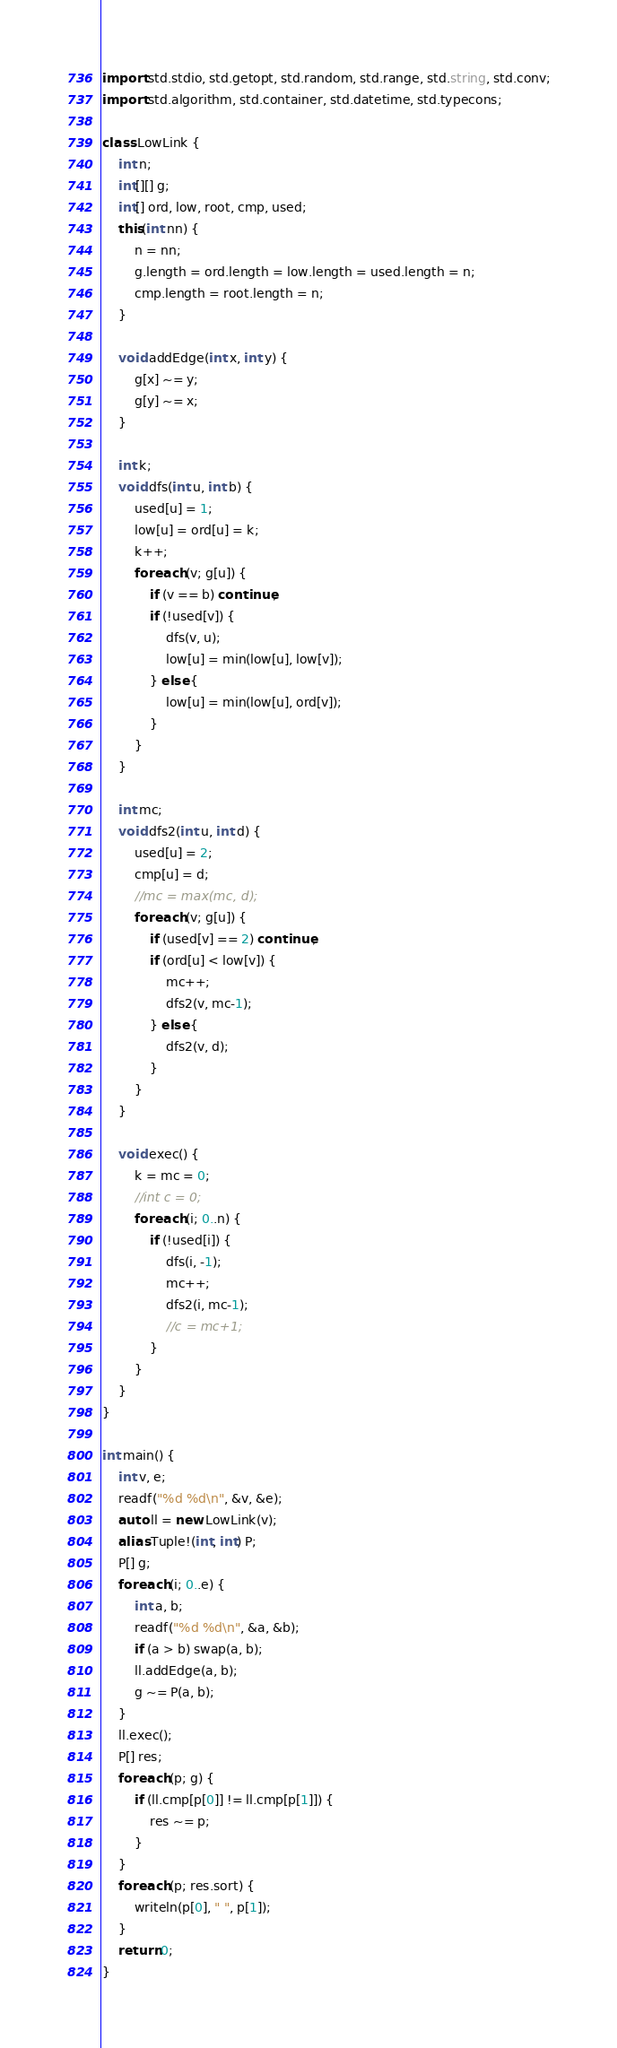Convert code to text. <code><loc_0><loc_0><loc_500><loc_500><_D_>import std.stdio, std.getopt, std.random, std.range, std.string, std.conv;
import std.algorithm, std.container, std.datetime, std.typecons;

class LowLink {
	int n;
	int[][] g;
	int[] ord, low, root, cmp, used;
	this(int nn) {
		n = nn;
		g.length = ord.length = low.length = used.length = n;
		cmp.length = root.length = n;
	}

	void addEdge(int x, int y) {
		g[x] ~= y;
		g[y] ~= x;
	}

	int k;
	void dfs(int u, int b) {
		used[u] = 1;
		low[u] = ord[u] = k;
		k++;
		foreach (v; g[u]) {
			if (v == b) continue;
			if (!used[v]) {
				dfs(v, u);
				low[u] = min(low[u], low[v]);
			} else {
				low[u] = min(low[u], ord[v]);
			}
		}
	}

	int mc;
	void dfs2(int u, int d) {
		used[u] = 2;
		cmp[u] = d;
		//mc = max(mc, d);
		foreach (v; g[u]) {
			if (used[v] == 2) continue;
			if (ord[u] < low[v]) {
				mc++;
				dfs2(v, mc-1);
			} else {
				dfs2(v, d);
			}
		}
	}

	void exec() {
		k = mc = 0;
		//int c = 0;
		foreach (i; 0..n) {
			if (!used[i]) {
				dfs(i, -1);
				mc++;
				dfs2(i, mc-1);
				//c = mc+1;
			}
		}
	}
}

int main() {
	int v, e;
	readf("%d %d\n", &v, &e);
	auto ll = new LowLink(v);
	alias Tuple!(int, int) P;
	P[] g;
	foreach (i; 0..e) {
		int a, b;
		readf("%d %d\n", &a, &b);
		if (a > b) swap(a, b);
		ll.addEdge(a, b);
		g ~= P(a, b);
	}
	ll.exec();
	P[] res;
	foreach (p; g) {
		if (ll.cmp[p[0]] != ll.cmp[p[1]]) {
			res ~= p;
		}
	}
	foreach (p; res.sort) {
		writeln(p[0], " ", p[1]);
	}
    return 0;
}</code> 